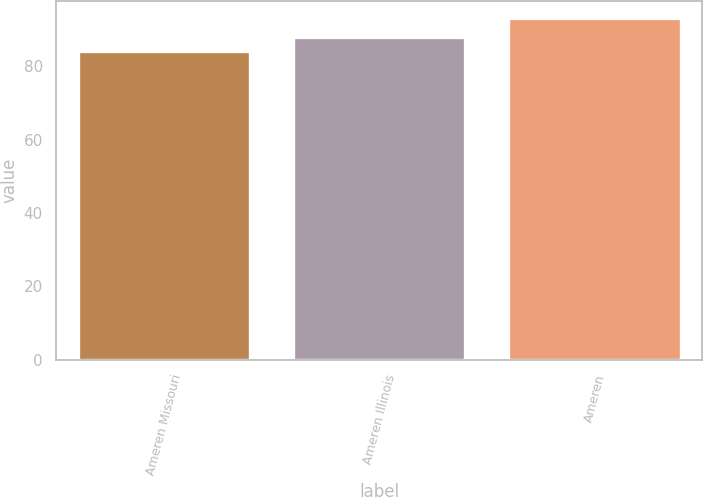Convert chart. <chart><loc_0><loc_0><loc_500><loc_500><bar_chart><fcel>Ameren Missouri<fcel>Ameren Illinois<fcel>Ameren<nl><fcel>84<fcel>88<fcel>93<nl></chart> 